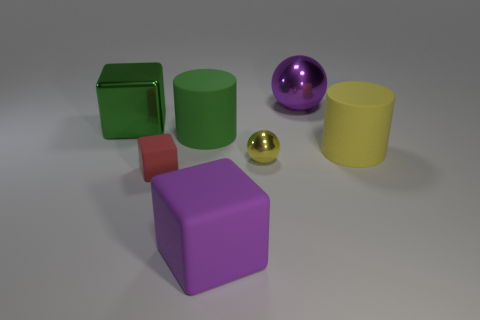Add 2 big green matte balls. How many objects exist? 9 Subtract all cylinders. How many objects are left? 5 Subtract 1 purple cubes. How many objects are left? 6 Subtract all metal spheres. Subtract all yellow shiny objects. How many objects are left? 4 Add 1 large shiny blocks. How many large shiny blocks are left? 2 Add 2 large matte things. How many large matte things exist? 5 